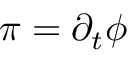<formula> <loc_0><loc_0><loc_500><loc_500>\pi = \partial _ { t } \phi</formula> 